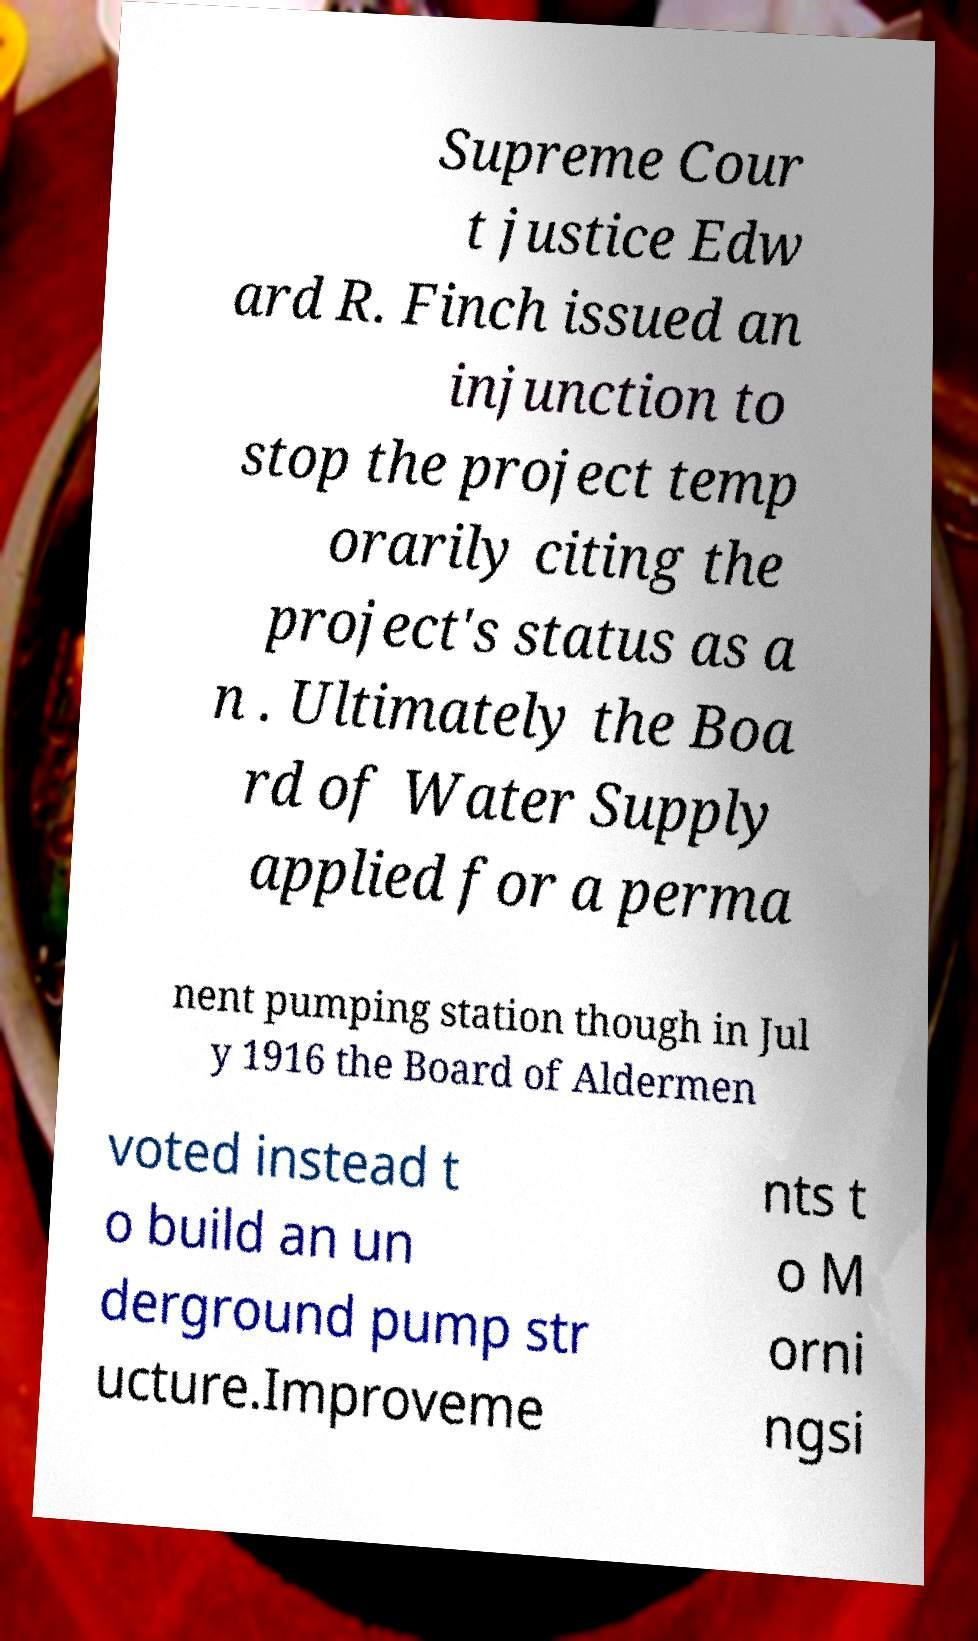I need the written content from this picture converted into text. Can you do that? Supreme Cour t justice Edw ard R. Finch issued an injunction to stop the project temp orarily citing the project's status as a n . Ultimately the Boa rd of Water Supply applied for a perma nent pumping station though in Jul y 1916 the Board of Aldermen voted instead t o build an un derground pump str ucture.Improveme nts t o M orni ngsi 